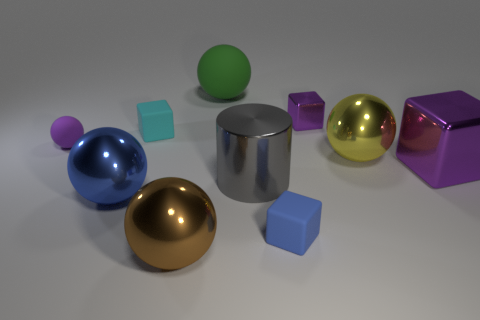What is the lighting like in the scene? Does it appear to be coming from a specific direction? The lighting in the scene is soft and diffuse, suggesting an evenly lit indoor environment, possibly a studio. Shadows on the ground indicate that the light source is coming from the upper right-hand side of the image, which gives the objects delicately defined shadows, enhancing their three-dimensional appearance.  Are there any reflections or textures on the surfaces that tell us more about the material of the objects? Certainly, the reflections on the spheres, particularly the gold and silver ones, and the glossy blue sphere, suggest they have a smooth, highly reflective surface. In contrast, the matte finish of the cubes and the cylinder indicates a less reflective, possibly textured surface, which absorbs more light than it reflects. 